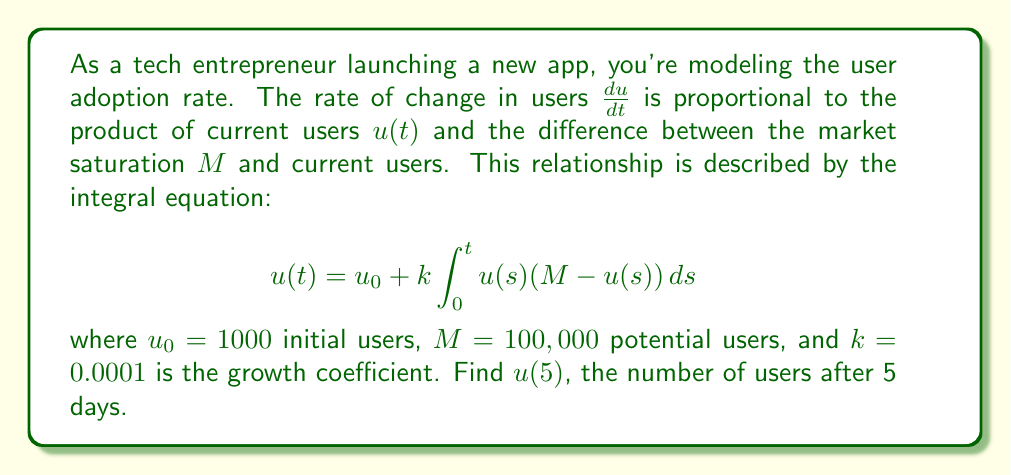Help me with this question. To solve this integral equation, we'll use the following steps:

1) First, we recognize this as a Volterra integral equation of the second kind.

2) We can transform this into a differential equation:
   $$\frac{du}{dt} = ku(M-u)$$

3) This is a logistic growth equation with solution:
   $$u(t) = \frac{M}{1 + (\frac{M}{u_0} - 1)e^{-kMt}}$$

4) Now, let's substitute our values:
   $M = 100,000$, $u_0 = 1000$, $k = 0.0001$, $t = 5$

5) Calculating:
   $$u(5) = \frac{100000}{1 + (\frac{100000}{1000} - 1)e^{-0.0001 \cdot 100000 \cdot 5}}$$

6) Simplify:
   $$u(5) = \frac{100000}{1 + 99 \cdot e^{-50}}$$

7) Calculate:
   $$u(5) \approx 1150.37$$

8) Since we're dealing with users, we round to the nearest whole number.
Answer: 1150 users 